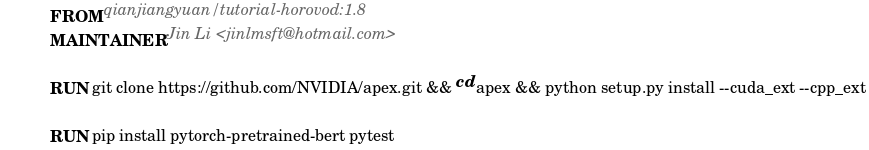<code> <loc_0><loc_0><loc_500><loc_500><_Dockerfile_>FROM qianjiangyuan/tutorial-horovod:1.8
MAINTAINER Jin Li <jinlmsft@hotmail.com>

RUN git clone https://github.com/NVIDIA/apex.git && cd apex && python setup.py install --cuda_ext --cpp_ext

RUN pip install pytorch-pretrained-bert pytest
</code> 